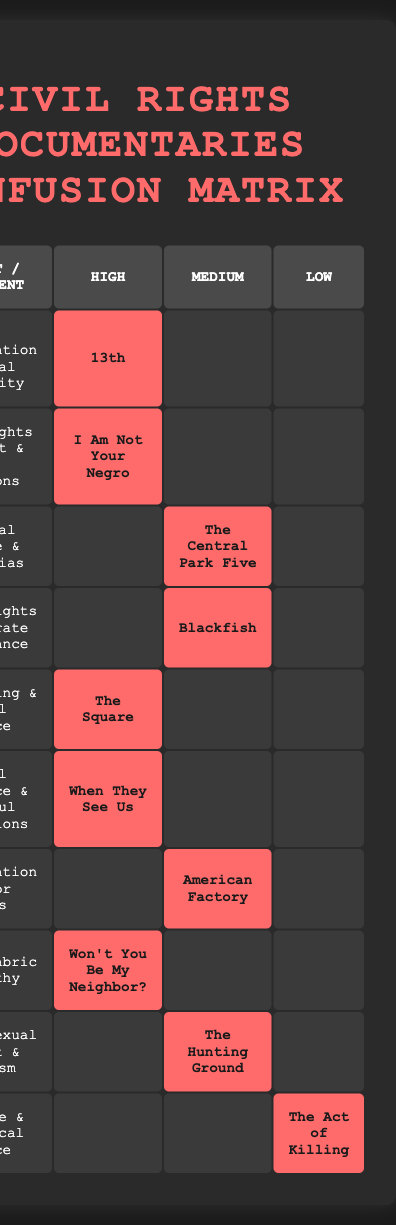What documentaries have a high viewer engagement? The table shows that the following documentaries have high viewer engagement: "13th", "I Am Not Your Negro", "The Square", "When They See Us", and "Won't You Be My Neighbor?". These titles are clearly marked under the "High" column for viewer engagement.
Answer: 13th, I Am Not Your Negro, The Square, When They See Us, Won't You Be My Neighbor? Which documentary has the lowest viewer engagement? In the "Low" column of the table, only "The Act of Killing" is listed, indicating it has the lowest viewer engagement among the documentaries.
Answer: The Act of Killing How many documentaries have a mixed critical reception? By examining the table, "Blackfish" and "The Hunting Ground" are marked as having mixed critical reception, which totals two documentaries.
Answer: 2 Is there any documentary that has both high viewer engagement and a positive critical reception? Yes, several documentaries are noted for having high viewer engagement and positive critical reception, as indicated in the table: "13th", "I Am Not Your Negro", "The Square", "When They See Us", and "Won't You Be My Neighbor?".
Answer: Yes What is the subject of the documentary with medium viewer engagement that discusses criminal justice? The documentary "The Central Park Five" discusses criminal justice and has medium viewer engagement, as indicated in its row of the table under both the Medium column and the Criminal Justice & Media Bias subject.
Answer: Criminal Justice & Media Bias How many documentaries have a positive critical reception but medium viewer engagement? The table indicates three documentaries with a positive critical reception that also have medium viewer engagement: "The Central Park Five", "Blackfish", and "American Factory". Adding these provides the total.
Answer: 3 Which subject has a high viewer engagement but does not have a documentary with a mixed critical reception? By looking at the table, the subjects "Mass Incarceration & Racial Inequality", "Civil Rights Movement & Race Relations", "Arab Spring & Social Justice", "Racial Injustice & Wrongful Convictions", and "Social Fabric & Empathy" all have a documentary listed under high viewer engagement but do not have any with mixed critical reception.
Answer: Mass Incarceration & Racial Inequality, Civil Rights Movement & Race Relations, Arab Spring & Social Justice, Racial Injustice & Wrongful Convictions, Social Fabric & Empathy How does the critical reception vary with different engagement levels among the documentaries? The table demonstrates that documentaries with high viewer engagement tend to lean towards a positive critical reception. Conversely, "Blackfish" and "The Hunting Ground" received a mixed reception despite medium viewer engagement. Thus, it suggests a trend where higher engagement often correlates with more favorable critical reception.
Answer: Higher engagement tends to mean a positive reception 